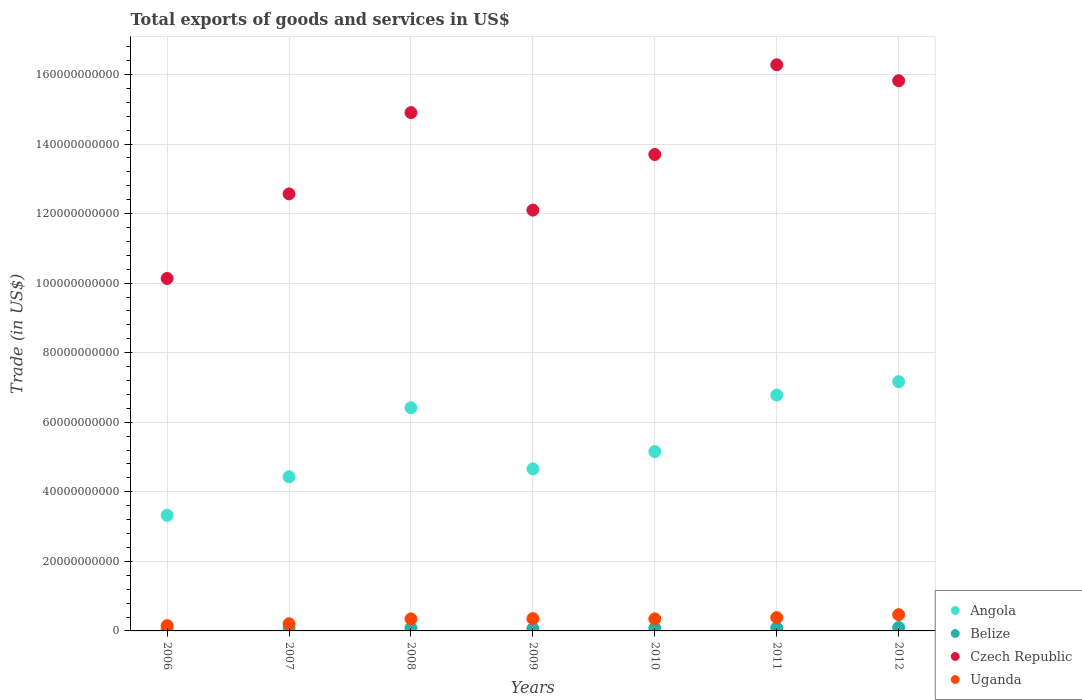What is the total exports of goods and services in Angola in 2012?
Offer a very short reply. 7.17e+1. Across all years, what is the maximum total exports of goods and services in Uganda?
Keep it short and to the point. 4.68e+09. Across all years, what is the minimum total exports of goods and services in Belize?
Make the answer very short. 6.90e+08. In which year was the total exports of goods and services in Angola minimum?
Your answer should be very brief. 2006. What is the total total exports of goods and services in Uganda in the graph?
Give a very brief answer. 2.25e+1. What is the difference between the total exports of goods and services in Uganda in 2008 and that in 2012?
Your answer should be very brief. -1.22e+09. What is the difference between the total exports of goods and services in Czech Republic in 2008 and the total exports of goods and services in Angola in 2009?
Make the answer very short. 1.02e+11. What is the average total exports of goods and services in Belize per year?
Offer a terse response. 8.24e+08. In the year 2007, what is the difference between the total exports of goods and services in Czech Republic and total exports of goods and services in Uganda?
Provide a short and direct response. 1.24e+11. In how many years, is the total exports of goods and services in Belize greater than 124000000000 US$?
Your answer should be compact. 0. What is the ratio of the total exports of goods and services in Czech Republic in 2009 to that in 2012?
Your response must be concise. 0.76. What is the difference between the highest and the second highest total exports of goods and services in Belize?
Offer a terse response. 8.93e+07. What is the difference between the highest and the lowest total exports of goods and services in Belize?
Your response must be concise. 2.93e+08. Does the total exports of goods and services in Uganda monotonically increase over the years?
Your response must be concise. No. Is the total exports of goods and services in Uganda strictly greater than the total exports of goods and services in Czech Republic over the years?
Give a very brief answer. No. Is the total exports of goods and services in Angola strictly less than the total exports of goods and services in Czech Republic over the years?
Ensure brevity in your answer.  Yes. How many years are there in the graph?
Provide a short and direct response. 7. Where does the legend appear in the graph?
Your answer should be compact. Bottom right. How many legend labels are there?
Your answer should be compact. 4. How are the legend labels stacked?
Keep it short and to the point. Vertical. What is the title of the graph?
Keep it short and to the point. Total exports of goods and services in US$. What is the label or title of the X-axis?
Your answer should be compact. Years. What is the label or title of the Y-axis?
Ensure brevity in your answer.  Trade (in US$). What is the Trade (in US$) of Angola in 2006?
Keep it short and to the point. 3.32e+1. What is the Trade (in US$) of Belize in 2006?
Offer a terse response. 7.44e+08. What is the Trade (in US$) in Czech Republic in 2006?
Make the answer very short. 1.01e+11. What is the Trade (in US$) of Uganda in 2006?
Offer a terse response. 1.52e+09. What is the Trade (in US$) in Angola in 2007?
Provide a short and direct response. 4.43e+1. What is the Trade (in US$) in Belize in 2007?
Your response must be concise. 7.88e+08. What is the Trade (in US$) of Czech Republic in 2007?
Ensure brevity in your answer.  1.26e+11. What is the Trade (in US$) in Uganda in 2007?
Offer a terse response. 2.06e+09. What is the Trade (in US$) in Angola in 2008?
Ensure brevity in your answer.  6.42e+1. What is the Trade (in US$) in Belize in 2008?
Your response must be concise. 8.54e+08. What is the Trade (in US$) of Czech Republic in 2008?
Offer a very short reply. 1.49e+11. What is the Trade (in US$) in Uganda in 2008?
Your answer should be very brief. 3.46e+09. What is the Trade (in US$) in Angola in 2009?
Your answer should be compact. 4.66e+1. What is the Trade (in US$) in Belize in 2009?
Offer a very short reply. 6.90e+08. What is the Trade (in US$) in Czech Republic in 2009?
Provide a short and direct response. 1.21e+11. What is the Trade (in US$) in Uganda in 2009?
Offer a very short reply. 3.54e+09. What is the Trade (in US$) in Angola in 2010?
Provide a succinct answer. 5.16e+1. What is the Trade (in US$) of Belize in 2010?
Your response must be concise. 8.13e+08. What is the Trade (in US$) in Czech Republic in 2010?
Ensure brevity in your answer.  1.37e+11. What is the Trade (in US$) of Uganda in 2010?
Your answer should be compact. 3.46e+09. What is the Trade (in US$) of Angola in 2011?
Make the answer very short. 6.78e+1. What is the Trade (in US$) of Belize in 2011?
Your response must be concise. 8.94e+08. What is the Trade (in US$) of Czech Republic in 2011?
Give a very brief answer. 1.63e+11. What is the Trade (in US$) in Uganda in 2011?
Offer a very short reply. 3.84e+09. What is the Trade (in US$) in Angola in 2012?
Provide a succinct answer. 7.17e+1. What is the Trade (in US$) of Belize in 2012?
Your answer should be compact. 9.83e+08. What is the Trade (in US$) of Czech Republic in 2012?
Provide a succinct answer. 1.58e+11. What is the Trade (in US$) of Uganda in 2012?
Give a very brief answer. 4.68e+09. Across all years, what is the maximum Trade (in US$) in Angola?
Your response must be concise. 7.17e+1. Across all years, what is the maximum Trade (in US$) in Belize?
Provide a succinct answer. 9.83e+08. Across all years, what is the maximum Trade (in US$) of Czech Republic?
Ensure brevity in your answer.  1.63e+11. Across all years, what is the maximum Trade (in US$) of Uganda?
Your response must be concise. 4.68e+09. Across all years, what is the minimum Trade (in US$) in Angola?
Keep it short and to the point. 3.32e+1. Across all years, what is the minimum Trade (in US$) of Belize?
Your response must be concise. 6.90e+08. Across all years, what is the minimum Trade (in US$) in Czech Republic?
Offer a very short reply. 1.01e+11. Across all years, what is the minimum Trade (in US$) of Uganda?
Your answer should be very brief. 1.52e+09. What is the total Trade (in US$) of Angola in the graph?
Provide a short and direct response. 3.79e+11. What is the total Trade (in US$) of Belize in the graph?
Offer a terse response. 5.77e+09. What is the total Trade (in US$) in Czech Republic in the graph?
Keep it short and to the point. 9.55e+11. What is the total Trade (in US$) of Uganda in the graph?
Provide a succinct answer. 2.25e+1. What is the difference between the Trade (in US$) of Angola in 2006 and that in 2007?
Provide a succinct answer. -1.11e+1. What is the difference between the Trade (in US$) of Belize in 2006 and that in 2007?
Your response must be concise. -4.42e+07. What is the difference between the Trade (in US$) of Czech Republic in 2006 and that in 2007?
Your answer should be compact. -2.43e+1. What is the difference between the Trade (in US$) in Uganda in 2006 and that in 2007?
Your response must be concise. -5.37e+08. What is the difference between the Trade (in US$) in Angola in 2006 and that in 2008?
Your response must be concise. -3.09e+1. What is the difference between the Trade (in US$) of Belize in 2006 and that in 2008?
Ensure brevity in your answer.  -1.09e+08. What is the difference between the Trade (in US$) in Czech Republic in 2006 and that in 2008?
Provide a succinct answer. -4.77e+1. What is the difference between the Trade (in US$) of Uganda in 2006 and that in 2008?
Your response must be concise. -1.94e+09. What is the difference between the Trade (in US$) of Angola in 2006 and that in 2009?
Your answer should be very brief. -1.34e+1. What is the difference between the Trade (in US$) of Belize in 2006 and that in 2009?
Your answer should be compact. 5.41e+07. What is the difference between the Trade (in US$) of Czech Republic in 2006 and that in 2009?
Provide a succinct answer. -1.97e+1. What is the difference between the Trade (in US$) in Uganda in 2006 and that in 2009?
Give a very brief answer. -2.02e+09. What is the difference between the Trade (in US$) of Angola in 2006 and that in 2010?
Offer a terse response. -1.83e+1. What is the difference between the Trade (in US$) in Belize in 2006 and that in 2010?
Provide a succinct answer. -6.90e+07. What is the difference between the Trade (in US$) of Czech Republic in 2006 and that in 2010?
Ensure brevity in your answer.  -3.57e+1. What is the difference between the Trade (in US$) in Uganda in 2006 and that in 2010?
Your answer should be very brief. -1.94e+09. What is the difference between the Trade (in US$) in Angola in 2006 and that in 2011?
Offer a very short reply. -3.46e+1. What is the difference between the Trade (in US$) in Belize in 2006 and that in 2011?
Offer a very short reply. -1.49e+08. What is the difference between the Trade (in US$) in Czech Republic in 2006 and that in 2011?
Make the answer very short. -6.15e+1. What is the difference between the Trade (in US$) of Uganda in 2006 and that in 2011?
Your answer should be compact. -2.32e+09. What is the difference between the Trade (in US$) of Angola in 2006 and that in 2012?
Provide a short and direct response. -3.84e+1. What is the difference between the Trade (in US$) of Belize in 2006 and that in 2012?
Ensure brevity in your answer.  -2.39e+08. What is the difference between the Trade (in US$) of Czech Republic in 2006 and that in 2012?
Offer a very short reply. -5.69e+1. What is the difference between the Trade (in US$) of Uganda in 2006 and that in 2012?
Offer a terse response. -3.16e+09. What is the difference between the Trade (in US$) of Angola in 2007 and that in 2008?
Ensure brevity in your answer.  -1.98e+1. What is the difference between the Trade (in US$) in Belize in 2007 and that in 2008?
Your response must be concise. -6.52e+07. What is the difference between the Trade (in US$) of Czech Republic in 2007 and that in 2008?
Your answer should be very brief. -2.34e+1. What is the difference between the Trade (in US$) of Uganda in 2007 and that in 2008?
Provide a short and direct response. -1.40e+09. What is the difference between the Trade (in US$) in Angola in 2007 and that in 2009?
Give a very brief answer. -2.28e+09. What is the difference between the Trade (in US$) of Belize in 2007 and that in 2009?
Your answer should be compact. 9.82e+07. What is the difference between the Trade (in US$) in Czech Republic in 2007 and that in 2009?
Your response must be concise. 4.67e+09. What is the difference between the Trade (in US$) of Uganda in 2007 and that in 2009?
Your answer should be compact. -1.49e+09. What is the difference between the Trade (in US$) in Angola in 2007 and that in 2010?
Your response must be concise. -7.25e+09. What is the difference between the Trade (in US$) of Belize in 2007 and that in 2010?
Offer a terse response. -2.49e+07. What is the difference between the Trade (in US$) in Czech Republic in 2007 and that in 2010?
Make the answer very short. -1.13e+1. What is the difference between the Trade (in US$) in Uganda in 2007 and that in 2010?
Give a very brief answer. -1.40e+09. What is the difference between the Trade (in US$) in Angola in 2007 and that in 2011?
Your answer should be compact. -2.35e+1. What is the difference between the Trade (in US$) in Belize in 2007 and that in 2011?
Your response must be concise. -1.05e+08. What is the difference between the Trade (in US$) of Czech Republic in 2007 and that in 2011?
Your response must be concise. -3.71e+1. What is the difference between the Trade (in US$) of Uganda in 2007 and that in 2011?
Keep it short and to the point. -1.78e+09. What is the difference between the Trade (in US$) in Angola in 2007 and that in 2012?
Your response must be concise. -2.73e+1. What is the difference between the Trade (in US$) of Belize in 2007 and that in 2012?
Offer a very short reply. -1.94e+08. What is the difference between the Trade (in US$) in Czech Republic in 2007 and that in 2012?
Keep it short and to the point. -3.25e+1. What is the difference between the Trade (in US$) of Uganda in 2007 and that in 2012?
Offer a terse response. -2.62e+09. What is the difference between the Trade (in US$) of Angola in 2008 and that in 2009?
Your answer should be very brief. 1.76e+1. What is the difference between the Trade (in US$) of Belize in 2008 and that in 2009?
Offer a very short reply. 1.63e+08. What is the difference between the Trade (in US$) of Czech Republic in 2008 and that in 2009?
Offer a terse response. 2.80e+1. What is the difference between the Trade (in US$) of Uganda in 2008 and that in 2009?
Your answer should be very brief. -8.52e+07. What is the difference between the Trade (in US$) in Angola in 2008 and that in 2010?
Make the answer very short. 1.26e+1. What is the difference between the Trade (in US$) of Belize in 2008 and that in 2010?
Your answer should be very brief. 4.03e+07. What is the difference between the Trade (in US$) of Czech Republic in 2008 and that in 2010?
Offer a very short reply. 1.20e+1. What is the difference between the Trade (in US$) of Uganda in 2008 and that in 2010?
Ensure brevity in your answer.  -1.05e+06. What is the difference between the Trade (in US$) in Angola in 2008 and that in 2011?
Offer a very short reply. -3.65e+09. What is the difference between the Trade (in US$) in Belize in 2008 and that in 2011?
Keep it short and to the point. -4.00e+07. What is the difference between the Trade (in US$) of Czech Republic in 2008 and that in 2011?
Your response must be concise. -1.38e+1. What is the difference between the Trade (in US$) of Uganda in 2008 and that in 2011?
Give a very brief answer. -3.80e+08. What is the difference between the Trade (in US$) in Angola in 2008 and that in 2012?
Make the answer very short. -7.50e+09. What is the difference between the Trade (in US$) in Belize in 2008 and that in 2012?
Give a very brief answer. -1.29e+08. What is the difference between the Trade (in US$) of Czech Republic in 2008 and that in 2012?
Make the answer very short. -9.17e+09. What is the difference between the Trade (in US$) of Uganda in 2008 and that in 2012?
Your response must be concise. -1.22e+09. What is the difference between the Trade (in US$) in Angola in 2009 and that in 2010?
Provide a succinct answer. -4.98e+09. What is the difference between the Trade (in US$) of Belize in 2009 and that in 2010?
Provide a succinct answer. -1.23e+08. What is the difference between the Trade (in US$) of Czech Republic in 2009 and that in 2010?
Offer a terse response. -1.60e+1. What is the difference between the Trade (in US$) in Uganda in 2009 and that in 2010?
Keep it short and to the point. 8.41e+07. What is the difference between the Trade (in US$) of Angola in 2009 and that in 2011?
Your answer should be very brief. -2.12e+1. What is the difference between the Trade (in US$) in Belize in 2009 and that in 2011?
Give a very brief answer. -2.03e+08. What is the difference between the Trade (in US$) in Czech Republic in 2009 and that in 2011?
Offer a terse response. -4.18e+1. What is the difference between the Trade (in US$) of Uganda in 2009 and that in 2011?
Give a very brief answer. -2.95e+08. What is the difference between the Trade (in US$) in Angola in 2009 and that in 2012?
Keep it short and to the point. -2.51e+1. What is the difference between the Trade (in US$) in Belize in 2009 and that in 2012?
Make the answer very short. -2.93e+08. What is the difference between the Trade (in US$) in Czech Republic in 2009 and that in 2012?
Offer a very short reply. -3.72e+1. What is the difference between the Trade (in US$) of Uganda in 2009 and that in 2012?
Provide a succinct answer. -1.13e+09. What is the difference between the Trade (in US$) in Angola in 2010 and that in 2011?
Provide a succinct answer. -1.62e+1. What is the difference between the Trade (in US$) of Belize in 2010 and that in 2011?
Make the answer very short. -8.03e+07. What is the difference between the Trade (in US$) in Czech Republic in 2010 and that in 2011?
Make the answer very short. -2.58e+1. What is the difference between the Trade (in US$) in Uganda in 2010 and that in 2011?
Ensure brevity in your answer.  -3.79e+08. What is the difference between the Trade (in US$) in Angola in 2010 and that in 2012?
Provide a short and direct response. -2.01e+1. What is the difference between the Trade (in US$) in Belize in 2010 and that in 2012?
Keep it short and to the point. -1.70e+08. What is the difference between the Trade (in US$) of Czech Republic in 2010 and that in 2012?
Your response must be concise. -2.12e+1. What is the difference between the Trade (in US$) in Uganda in 2010 and that in 2012?
Your response must be concise. -1.22e+09. What is the difference between the Trade (in US$) in Angola in 2011 and that in 2012?
Your answer should be very brief. -3.85e+09. What is the difference between the Trade (in US$) of Belize in 2011 and that in 2012?
Provide a short and direct response. -8.93e+07. What is the difference between the Trade (in US$) in Czech Republic in 2011 and that in 2012?
Provide a succinct answer. 4.59e+09. What is the difference between the Trade (in US$) of Uganda in 2011 and that in 2012?
Your response must be concise. -8.39e+08. What is the difference between the Trade (in US$) of Angola in 2006 and the Trade (in US$) of Belize in 2007?
Offer a very short reply. 3.25e+1. What is the difference between the Trade (in US$) of Angola in 2006 and the Trade (in US$) of Czech Republic in 2007?
Make the answer very short. -9.24e+1. What is the difference between the Trade (in US$) of Angola in 2006 and the Trade (in US$) of Uganda in 2007?
Make the answer very short. 3.12e+1. What is the difference between the Trade (in US$) in Belize in 2006 and the Trade (in US$) in Czech Republic in 2007?
Keep it short and to the point. -1.25e+11. What is the difference between the Trade (in US$) in Belize in 2006 and the Trade (in US$) in Uganda in 2007?
Offer a terse response. -1.31e+09. What is the difference between the Trade (in US$) of Czech Republic in 2006 and the Trade (in US$) of Uganda in 2007?
Keep it short and to the point. 9.93e+1. What is the difference between the Trade (in US$) of Angola in 2006 and the Trade (in US$) of Belize in 2008?
Your response must be concise. 3.24e+1. What is the difference between the Trade (in US$) of Angola in 2006 and the Trade (in US$) of Czech Republic in 2008?
Offer a terse response. -1.16e+11. What is the difference between the Trade (in US$) in Angola in 2006 and the Trade (in US$) in Uganda in 2008?
Your response must be concise. 2.98e+1. What is the difference between the Trade (in US$) in Belize in 2006 and the Trade (in US$) in Czech Republic in 2008?
Ensure brevity in your answer.  -1.48e+11. What is the difference between the Trade (in US$) in Belize in 2006 and the Trade (in US$) in Uganda in 2008?
Provide a succinct answer. -2.71e+09. What is the difference between the Trade (in US$) in Czech Republic in 2006 and the Trade (in US$) in Uganda in 2008?
Make the answer very short. 9.79e+1. What is the difference between the Trade (in US$) of Angola in 2006 and the Trade (in US$) of Belize in 2009?
Provide a short and direct response. 3.26e+1. What is the difference between the Trade (in US$) of Angola in 2006 and the Trade (in US$) of Czech Republic in 2009?
Your answer should be compact. -8.78e+1. What is the difference between the Trade (in US$) in Angola in 2006 and the Trade (in US$) in Uganda in 2009?
Ensure brevity in your answer.  2.97e+1. What is the difference between the Trade (in US$) of Belize in 2006 and the Trade (in US$) of Czech Republic in 2009?
Ensure brevity in your answer.  -1.20e+11. What is the difference between the Trade (in US$) in Belize in 2006 and the Trade (in US$) in Uganda in 2009?
Provide a short and direct response. -2.80e+09. What is the difference between the Trade (in US$) of Czech Republic in 2006 and the Trade (in US$) of Uganda in 2009?
Offer a very short reply. 9.78e+1. What is the difference between the Trade (in US$) of Angola in 2006 and the Trade (in US$) of Belize in 2010?
Give a very brief answer. 3.24e+1. What is the difference between the Trade (in US$) in Angola in 2006 and the Trade (in US$) in Czech Republic in 2010?
Your answer should be compact. -1.04e+11. What is the difference between the Trade (in US$) in Angola in 2006 and the Trade (in US$) in Uganda in 2010?
Provide a short and direct response. 2.98e+1. What is the difference between the Trade (in US$) of Belize in 2006 and the Trade (in US$) of Czech Republic in 2010?
Provide a short and direct response. -1.36e+11. What is the difference between the Trade (in US$) in Belize in 2006 and the Trade (in US$) in Uganda in 2010?
Keep it short and to the point. -2.71e+09. What is the difference between the Trade (in US$) in Czech Republic in 2006 and the Trade (in US$) in Uganda in 2010?
Provide a short and direct response. 9.79e+1. What is the difference between the Trade (in US$) in Angola in 2006 and the Trade (in US$) in Belize in 2011?
Keep it short and to the point. 3.24e+1. What is the difference between the Trade (in US$) in Angola in 2006 and the Trade (in US$) in Czech Republic in 2011?
Provide a succinct answer. -1.30e+11. What is the difference between the Trade (in US$) of Angola in 2006 and the Trade (in US$) of Uganda in 2011?
Provide a short and direct response. 2.94e+1. What is the difference between the Trade (in US$) of Belize in 2006 and the Trade (in US$) of Czech Republic in 2011?
Provide a short and direct response. -1.62e+11. What is the difference between the Trade (in US$) of Belize in 2006 and the Trade (in US$) of Uganda in 2011?
Provide a short and direct response. -3.09e+09. What is the difference between the Trade (in US$) of Czech Republic in 2006 and the Trade (in US$) of Uganda in 2011?
Your answer should be very brief. 9.75e+1. What is the difference between the Trade (in US$) in Angola in 2006 and the Trade (in US$) in Belize in 2012?
Give a very brief answer. 3.23e+1. What is the difference between the Trade (in US$) of Angola in 2006 and the Trade (in US$) of Czech Republic in 2012?
Offer a very short reply. -1.25e+11. What is the difference between the Trade (in US$) in Angola in 2006 and the Trade (in US$) in Uganda in 2012?
Your response must be concise. 2.86e+1. What is the difference between the Trade (in US$) of Belize in 2006 and the Trade (in US$) of Czech Republic in 2012?
Provide a short and direct response. -1.57e+11. What is the difference between the Trade (in US$) of Belize in 2006 and the Trade (in US$) of Uganda in 2012?
Provide a succinct answer. -3.93e+09. What is the difference between the Trade (in US$) of Czech Republic in 2006 and the Trade (in US$) of Uganda in 2012?
Offer a very short reply. 9.67e+1. What is the difference between the Trade (in US$) of Angola in 2007 and the Trade (in US$) of Belize in 2008?
Your answer should be compact. 4.35e+1. What is the difference between the Trade (in US$) in Angola in 2007 and the Trade (in US$) in Czech Republic in 2008?
Your answer should be compact. -1.05e+11. What is the difference between the Trade (in US$) in Angola in 2007 and the Trade (in US$) in Uganda in 2008?
Your answer should be compact. 4.09e+1. What is the difference between the Trade (in US$) in Belize in 2007 and the Trade (in US$) in Czech Republic in 2008?
Your response must be concise. -1.48e+11. What is the difference between the Trade (in US$) of Belize in 2007 and the Trade (in US$) of Uganda in 2008?
Your answer should be very brief. -2.67e+09. What is the difference between the Trade (in US$) of Czech Republic in 2007 and the Trade (in US$) of Uganda in 2008?
Offer a terse response. 1.22e+11. What is the difference between the Trade (in US$) in Angola in 2007 and the Trade (in US$) in Belize in 2009?
Your response must be concise. 4.36e+1. What is the difference between the Trade (in US$) of Angola in 2007 and the Trade (in US$) of Czech Republic in 2009?
Provide a succinct answer. -7.67e+1. What is the difference between the Trade (in US$) in Angola in 2007 and the Trade (in US$) in Uganda in 2009?
Provide a succinct answer. 4.08e+1. What is the difference between the Trade (in US$) of Belize in 2007 and the Trade (in US$) of Czech Republic in 2009?
Provide a succinct answer. -1.20e+11. What is the difference between the Trade (in US$) of Belize in 2007 and the Trade (in US$) of Uganda in 2009?
Give a very brief answer. -2.75e+09. What is the difference between the Trade (in US$) in Czech Republic in 2007 and the Trade (in US$) in Uganda in 2009?
Provide a short and direct response. 1.22e+11. What is the difference between the Trade (in US$) in Angola in 2007 and the Trade (in US$) in Belize in 2010?
Make the answer very short. 4.35e+1. What is the difference between the Trade (in US$) of Angola in 2007 and the Trade (in US$) of Czech Republic in 2010?
Offer a terse response. -9.27e+1. What is the difference between the Trade (in US$) of Angola in 2007 and the Trade (in US$) of Uganda in 2010?
Offer a very short reply. 4.09e+1. What is the difference between the Trade (in US$) of Belize in 2007 and the Trade (in US$) of Czech Republic in 2010?
Keep it short and to the point. -1.36e+11. What is the difference between the Trade (in US$) in Belize in 2007 and the Trade (in US$) in Uganda in 2010?
Your answer should be very brief. -2.67e+09. What is the difference between the Trade (in US$) in Czech Republic in 2007 and the Trade (in US$) in Uganda in 2010?
Your response must be concise. 1.22e+11. What is the difference between the Trade (in US$) of Angola in 2007 and the Trade (in US$) of Belize in 2011?
Your response must be concise. 4.34e+1. What is the difference between the Trade (in US$) of Angola in 2007 and the Trade (in US$) of Czech Republic in 2011?
Provide a succinct answer. -1.18e+11. What is the difference between the Trade (in US$) of Angola in 2007 and the Trade (in US$) of Uganda in 2011?
Provide a succinct answer. 4.05e+1. What is the difference between the Trade (in US$) of Belize in 2007 and the Trade (in US$) of Czech Republic in 2011?
Make the answer very short. -1.62e+11. What is the difference between the Trade (in US$) in Belize in 2007 and the Trade (in US$) in Uganda in 2011?
Provide a short and direct response. -3.05e+09. What is the difference between the Trade (in US$) in Czech Republic in 2007 and the Trade (in US$) in Uganda in 2011?
Provide a succinct answer. 1.22e+11. What is the difference between the Trade (in US$) in Angola in 2007 and the Trade (in US$) in Belize in 2012?
Ensure brevity in your answer.  4.33e+1. What is the difference between the Trade (in US$) of Angola in 2007 and the Trade (in US$) of Czech Republic in 2012?
Keep it short and to the point. -1.14e+11. What is the difference between the Trade (in US$) in Angola in 2007 and the Trade (in US$) in Uganda in 2012?
Give a very brief answer. 3.96e+1. What is the difference between the Trade (in US$) in Belize in 2007 and the Trade (in US$) in Czech Republic in 2012?
Offer a terse response. -1.57e+11. What is the difference between the Trade (in US$) in Belize in 2007 and the Trade (in US$) in Uganda in 2012?
Give a very brief answer. -3.89e+09. What is the difference between the Trade (in US$) in Czech Republic in 2007 and the Trade (in US$) in Uganda in 2012?
Provide a succinct answer. 1.21e+11. What is the difference between the Trade (in US$) of Angola in 2008 and the Trade (in US$) of Belize in 2009?
Your answer should be compact. 6.35e+1. What is the difference between the Trade (in US$) in Angola in 2008 and the Trade (in US$) in Czech Republic in 2009?
Your answer should be compact. -5.68e+1. What is the difference between the Trade (in US$) of Angola in 2008 and the Trade (in US$) of Uganda in 2009?
Ensure brevity in your answer.  6.06e+1. What is the difference between the Trade (in US$) of Belize in 2008 and the Trade (in US$) of Czech Republic in 2009?
Offer a very short reply. -1.20e+11. What is the difference between the Trade (in US$) of Belize in 2008 and the Trade (in US$) of Uganda in 2009?
Offer a very short reply. -2.69e+09. What is the difference between the Trade (in US$) in Czech Republic in 2008 and the Trade (in US$) in Uganda in 2009?
Make the answer very short. 1.45e+11. What is the difference between the Trade (in US$) of Angola in 2008 and the Trade (in US$) of Belize in 2010?
Your answer should be very brief. 6.34e+1. What is the difference between the Trade (in US$) of Angola in 2008 and the Trade (in US$) of Czech Republic in 2010?
Your answer should be very brief. -7.28e+1. What is the difference between the Trade (in US$) in Angola in 2008 and the Trade (in US$) in Uganda in 2010?
Provide a short and direct response. 6.07e+1. What is the difference between the Trade (in US$) in Belize in 2008 and the Trade (in US$) in Czech Republic in 2010?
Give a very brief answer. -1.36e+11. What is the difference between the Trade (in US$) of Belize in 2008 and the Trade (in US$) of Uganda in 2010?
Provide a succinct answer. -2.60e+09. What is the difference between the Trade (in US$) of Czech Republic in 2008 and the Trade (in US$) of Uganda in 2010?
Offer a terse response. 1.46e+11. What is the difference between the Trade (in US$) of Angola in 2008 and the Trade (in US$) of Belize in 2011?
Provide a succinct answer. 6.33e+1. What is the difference between the Trade (in US$) of Angola in 2008 and the Trade (in US$) of Czech Republic in 2011?
Provide a succinct answer. -9.86e+1. What is the difference between the Trade (in US$) of Angola in 2008 and the Trade (in US$) of Uganda in 2011?
Offer a very short reply. 6.03e+1. What is the difference between the Trade (in US$) in Belize in 2008 and the Trade (in US$) in Czech Republic in 2011?
Keep it short and to the point. -1.62e+11. What is the difference between the Trade (in US$) in Belize in 2008 and the Trade (in US$) in Uganda in 2011?
Give a very brief answer. -2.98e+09. What is the difference between the Trade (in US$) in Czech Republic in 2008 and the Trade (in US$) in Uganda in 2011?
Ensure brevity in your answer.  1.45e+11. What is the difference between the Trade (in US$) of Angola in 2008 and the Trade (in US$) of Belize in 2012?
Ensure brevity in your answer.  6.32e+1. What is the difference between the Trade (in US$) in Angola in 2008 and the Trade (in US$) in Czech Republic in 2012?
Your answer should be compact. -9.40e+1. What is the difference between the Trade (in US$) of Angola in 2008 and the Trade (in US$) of Uganda in 2012?
Your answer should be compact. 5.95e+1. What is the difference between the Trade (in US$) of Belize in 2008 and the Trade (in US$) of Czech Republic in 2012?
Provide a succinct answer. -1.57e+11. What is the difference between the Trade (in US$) of Belize in 2008 and the Trade (in US$) of Uganda in 2012?
Give a very brief answer. -3.82e+09. What is the difference between the Trade (in US$) of Czech Republic in 2008 and the Trade (in US$) of Uganda in 2012?
Your response must be concise. 1.44e+11. What is the difference between the Trade (in US$) of Angola in 2009 and the Trade (in US$) of Belize in 2010?
Provide a short and direct response. 4.58e+1. What is the difference between the Trade (in US$) of Angola in 2009 and the Trade (in US$) of Czech Republic in 2010?
Your response must be concise. -9.04e+1. What is the difference between the Trade (in US$) in Angola in 2009 and the Trade (in US$) in Uganda in 2010?
Offer a very short reply. 4.31e+1. What is the difference between the Trade (in US$) of Belize in 2009 and the Trade (in US$) of Czech Republic in 2010?
Offer a terse response. -1.36e+11. What is the difference between the Trade (in US$) of Belize in 2009 and the Trade (in US$) of Uganda in 2010?
Provide a short and direct response. -2.77e+09. What is the difference between the Trade (in US$) in Czech Republic in 2009 and the Trade (in US$) in Uganda in 2010?
Ensure brevity in your answer.  1.18e+11. What is the difference between the Trade (in US$) of Angola in 2009 and the Trade (in US$) of Belize in 2011?
Your answer should be very brief. 4.57e+1. What is the difference between the Trade (in US$) in Angola in 2009 and the Trade (in US$) in Czech Republic in 2011?
Provide a short and direct response. -1.16e+11. What is the difference between the Trade (in US$) of Angola in 2009 and the Trade (in US$) of Uganda in 2011?
Offer a very short reply. 4.28e+1. What is the difference between the Trade (in US$) of Belize in 2009 and the Trade (in US$) of Czech Republic in 2011?
Give a very brief answer. -1.62e+11. What is the difference between the Trade (in US$) in Belize in 2009 and the Trade (in US$) in Uganda in 2011?
Offer a terse response. -3.15e+09. What is the difference between the Trade (in US$) in Czech Republic in 2009 and the Trade (in US$) in Uganda in 2011?
Your response must be concise. 1.17e+11. What is the difference between the Trade (in US$) in Angola in 2009 and the Trade (in US$) in Belize in 2012?
Your answer should be very brief. 4.56e+1. What is the difference between the Trade (in US$) of Angola in 2009 and the Trade (in US$) of Czech Republic in 2012?
Your response must be concise. -1.12e+11. What is the difference between the Trade (in US$) of Angola in 2009 and the Trade (in US$) of Uganda in 2012?
Give a very brief answer. 4.19e+1. What is the difference between the Trade (in US$) of Belize in 2009 and the Trade (in US$) of Czech Republic in 2012?
Your answer should be compact. -1.58e+11. What is the difference between the Trade (in US$) in Belize in 2009 and the Trade (in US$) in Uganda in 2012?
Offer a terse response. -3.99e+09. What is the difference between the Trade (in US$) in Czech Republic in 2009 and the Trade (in US$) in Uganda in 2012?
Ensure brevity in your answer.  1.16e+11. What is the difference between the Trade (in US$) of Angola in 2010 and the Trade (in US$) of Belize in 2011?
Ensure brevity in your answer.  5.07e+1. What is the difference between the Trade (in US$) in Angola in 2010 and the Trade (in US$) in Czech Republic in 2011?
Give a very brief answer. -1.11e+11. What is the difference between the Trade (in US$) in Angola in 2010 and the Trade (in US$) in Uganda in 2011?
Your answer should be very brief. 4.77e+1. What is the difference between the Trade (in US$) in Belize in 2010 and the Trade (in US$) in Czech Republic in 2011?
Ensure brevity in your answer.  -1.62e+11. What is the difference between the Trade (in US$) of Belize in 2010 and the Trade (in US$) of Uganda in 2011?
Your answer should be compact. -3.02e+09. What is the difference between the Trade (in US$) of Czech Republic in 2010 and the Trade (in US$) of Uganda in 2011?
Give a very brief answer. 1.33e+11. What is the difference between the Trade (in US$) of Angola in 2010 and the Trade (in US$) of Belize in 2012?
Make the answer very short. 5.06e+1. What is the difference between the Trade (in US$) in Angola in 2010 and the Trade (in US$) in Czech Republic in 2012?
Make the answer very short. -1.07e+11. What is the difference between the Trade (in US$) of Angola in 2010 and the Trade (in US$) of Uganda in 2012?
Give a very brief answer. 4.69e+1. What is the difference between the Trade (in US$) in Belize in 2010 and the Trade (in US$) in Czech Republic in 2012?
Your response must be concise. -1.57e+11. What is the difference between the Trade (in US$) in Belize in 2010 and the Trade (in US$) in Uganda in 2012?
Your answer should be very brief. -3.86e+09. What is the difference between the Trade (in US$) of Czech Republic in 2010 and the Trade (in US$) of Uganda in 2012?
Ensure brevity in your answer.  1.32e+11. What is the difference between the Trade (in US$) in Angola in 2011 and the Trade (in US$) in Belize in 2012?
Provide a short and direct response. 6.68e+1. What is the difference between the Trade (in US$) in Angola in 2011 and the Trade (in US$) in Czech Republic in 2012?
Offer a terse response. -9.04e+1. What is the difference between the Trade (in US$) in Angola in 2011 and the Trade (in US$) in Uganda in 2012?
Your response must be concise. 6.31e+1. What is the difference between the Trade (in US$) in Belize in 2011 and the Trade (in US$) in Czech Republic in 2012?
Provide a succinct answer. -1.57e+11. What is the difference between the Trade (in US$) of Belize in 2011 and the Trade (in US$) of Uganda in 2012?
Make the answer very short. -3.78e+09. What is the difference between the Trade (in US$) in Czech Republic in 2011 and the Trade (in US$) in Uganda in 2012?
Keep it short and to the point. 1.58e+11. What is the average Trade (in US$) of Angola per year?
Your answer should be very brief. 5.42e+1. What is the average Trade (in US$) in Belize per year?
Offer a terse response. 8.24e+08. What is the average Trade (in US$) of Czech Republic per year?
Give a very brief answer. 1.36e+11. What is the average Trade (in US$) in Uganda per year?
Make the answer very short. 3.22e+09. In the year 2006, what is the difference between the Trade (in US$) of Angola and Trade (in US$) of Belize?
Offer a very short reply. 3.25e+1. In the year 2006, what is the difference between the Trade (in US$) of Angola and Trade (in US$) of Czech Republic?
Ensure brevity in your answer.  -6.81e+1. In the year 2006, what is the difference between the Trade (in US$) in Angola and Trade (in US$) in Uganda?
Your answer should be very brief. 3.17e+1. In the year 2006, what is the difference between the Trade (in US$) of Belize and Trade (in US$) of Czech Republic?
Keep it short and to the point. -1.01e+11. In the year 2006, what is the difference between the Trade (in US$) in Belize and Trade (in US$) in Uganda?
Offer a terse response. -7.75e+08. In the year 2006, what is the difference between the Trade (in US$) in Czech Republic and Trade (in US$) in Uganda?
Ensure brevity in your answer.  9.98e+1. In the year 2007, what is the difference between the Trade (in US$) of Angola and Trade (in US$) of Belize?
Offer a terse response. 4.35e+1. In the year 2007, what is the difference between the Trade (in US$) in Angola and Trade (in US$) in Czech Republic?
Give a very brief answer. -8.13e+1. In the year 2007, what is the difference between the Trade (in US$) of Angola and Trade (in US$) of Uganda?
Your response must be concise. 4.23e+1. In the year 2007, what is the difference between the Trade (in US$) in Belize and Trade (in US$) in Czech Republic?
Offer a very short reply. -1.25e+11. In the year 2007, what is the difference between the Trade (in US$) in Belize and Trade (in US$) in Uganda?
Ensure brevity in your answer.  -1.27e+09. In the year 2007, what is the difference between the Trade (in US$) in Czech Republic and Trade (in US$) in Uganda?
Offer a very short reply. 1.24e+11. In the year 2008, what is the difference between the Trade (in US$) of Angola and Trade (in US$) of Belize?
Provide a succinct answer. 6.33e+1. In the year 2008, what is the difference between the Trade (in US$) in Angola and Trade (in US$) in Czech Republic?
Your response must be concise. -8.49e+1. In the year 2008, what is the difference between the Trade (in US$) in Angola and Trade (in US$) in Uganda?
Your answer should be very brief. 6.07e+1. In the year 2008, what is the difference between the Trade (in US$) in Belize and Trade (in US$) in Czech Republic?
Provide a short and direct response. -1.48e+11. In the year 2008, what is the difference between the Trade (in US$) in Belize and Trade (in US$) in Uganda?
Keep it short and to the point. -2.60e+09. In the year 2008, what is the difference between the Trade (in US$) of Czech Republic and Trade (in US$) of Uganda?
Offer a very short reply. 1.46e+11. In the year 2009, what is the difference between the Trade (in US$) in Angola and Trade (in US$) in Belize?
Provide a short and direct response. 4.59e+1. In the year 2009, what is the difference between the Trade (in US$) of Angola and Trade (in US$) of Czech Republic?
Your response must be concise. -7.44e+1. In the year 2009, what is the difference between the Trade (in US$) of Angola and Trade (in US$) of Uganda?
Provide a short and direct response. 4.31e+1. In the year 2009, what is the difference between the Trade (in US$) of Belize and Trade (in US$) of Czech Republic?
Offer a very short reply. -1.20e+11. In the year 2009, what is the difference between the Trade (in US$) in Belize and Trade (in US$) in Uganda?
Your response must be concise. -2.85e+09. In the year 2009, what is the difference between the Trade (in US$) in Czech Republic and Trade (in US$) in Uganda?
Ensure brevity in your answer.  1.17e+11. In the year 2010, what is the difference between the Trade (in US$) in Angola and Trade (in US$) in Belize?
Keep it short and to the point. 5.08e+1. In the year 2010, what is the difference between the Trade (in US$) in Angola and Trade (in US$) in Czech Republic?
Your answer should be compact. -8.54e+1. In the year 2010, what is the difference between the Trade (in US$) in Angola and Trade (in US$) in Uganda?
Ensure brevity in your answer.  4.81e+1. In the year 2010, what is the difference between the Trade (in US$) in Belize and Trade (in US$) in Czech Republic?
Make the answer very short. -1.36e+11. In the year 2010, what is the difference between the Trade (in US$) of Belize and Trade (in US$) of Uganda?
Provide a short and direct response. -2.65e+09. In the year 2010, what is the difference between the Trade (in US$) of Czech Republic and Trade (in US$) of Uganda?
Keep it short and to the point. 1.34e+11. In the year 2011, what is the difference between the Trade (in US$) of Angola and Trade (in US$) of Belize?
Provide a succinct answer. 6.69e+1. In the year 2011, what is the difference between the Trade (in US$) of Angola and Trade (in US$) of Czech Republic?
Make the answer very short. -9.50e+1. In the year 2011, what is the difference between the Trade (in US$) of Angola and Trade (in US$) of Uganda?
Offer a terse response. 6.40e+1. In the year 2011, what is the difference between the Trade (in US$) in Belize and Trade (in US$) in Czech Republic?
Provide a succinct answer. -1.62e+11. In the year 2011, what is the difference between the Trade (in US$) in Belize and Trade (in US$) in Uganda?
Offer a very short reply. -2.94e+09. In the year 2011, what is the difference between the Trade (in US$) in Czech Republic and Trade (in US$) in Uganda?
Your response must be concise. 1.59e+11. In the year 2012, what is the difference between the Trade (in US$) of Angola and Trade (in US$) of Belize?
Provide a short and direct response. 7.07e+1. In the year 2012, what is the difference between the Trade (in US$) of Angola and Trade (in US$) of Czech Republic?
Your answer should be compact. -8.65e+1. In the year 2012, what is the difference between the Trade (in US$) in Angola and Trade (in US$) in Uganda?
Your response must be concise. 6.70e+1. In the year 2012, what is the difference between the Trade (in US$) in Belize and Trade (in US$) in Czech Republic?
Your answer should be very brief. -1.57e+11. In the year 2012, what is the difference between the Trade (in US$) of Belize and Trade (in US$) of Uganda?
Offer a very short reply. -3.69e+09. In the year 2012, what is the difference between the Trade (in US$) of Czech Republic and Trade (in US$) of Uganda?
Offer a very short reply. 1.54e+11. What is the ratio of the Trade (in US$) of Angola in 2006 to that in 2007?
Offer a very short reply. 0.75. What is the ratio of the Trade (in US$) in Belize in 2006 to that in 2007?
Offer a terse response. 0.94. What is the ratio of the Trade (in US$) of Czech Republic in 2006 to that in 2007?
Your answer should be compact. 0.81. What is the ratio of the Trade (in US$) of Uganda in 2006 to that in 2007?
Your response must be concise. 0.74. What is the ratio of the Trade (in US$) of Angola in 2006 to that in 2008?
Make the answer very short. 0.52. What is the ratio of the Trade (in US$) of Belize in 2006 to that in 2008?
Make the answer very short. 0.87. What is the ratio of the Trade (in US$) of Czech Republic in 2006 to that in 2008?
Your answer should be very brief. 0.68. What is the ratio of the Trade (in US$) in Uganda in 2006 to that in 2008?
Your answer should be compact. 0.44. What is the ratio of the Trade (in US$) in Angola in 2006 to that in 2009?
Offer a very short reply. 0.71. What is the ratio of the Trade (in US$) of Belize in 2006 to that in 2009?
Offer a very short reply. 1.08. What is the ratio of the Trade (in US$) of Czech Republic in 2006 to that in 2009?
Keep it short and to the point. 0.84. What is the ratio of the Trade (in US$) of Uganda in 2006 to that in 2009?
Offer a very short reply. 0.43. What is the ratio of the Trade (in US$) in Angola in 2006 to that in 2010?
Your answer should be compact. 0.64. What is the ratio of the Trade (in US$) in Belize in 2006 to that in 2010?
Make the answer very short. 0.92. What is the ratio of the Trade (in US$) of Czech Republic in 2006 to that in 2010?
Your answer should be compact. 0.74. What is the ratio of the Trade (in US$) in Uganda in 2006 to that in 2010?
Provide a succinct answer. 0.44. What is the ratio of the Trade (in US$) in Angola in 2006 to that in 2011?
Give a very brief answer. 0.49. What is the ratio of the Trade (in US$) in Belize in 2006 to that in 2011?
Your response must be concise. 0.83. What is the ratio of the Trade (in US$) of Czech Republic in 2006 to that in 2011?
Provide a succinct answer. 0.62. What is the ratio of the Trade (in US$) of Uganda in 2006 to that in 2011?
Your answer should be very brief. 0.4. What is the ratio of the Trade (in US$) of Angola in 2006 to that in 2012?
Make the answer very short. 0.46. What is the ratio of the Trade (in US$) in Belize in 2006 to that in 2012?
Provide a short and direct response. 0.76. What is the ratio of the Trade (in US$) of Czech Republic in 2006 to that in 2012?
Provide a short and direct response. 0.64. What is the ratio of the Trade (in US$) of Uganda in 2006 to that in 2012?
Your answer should be very brief. 0.32. What is the ratio of the Trade (in US$) in Angola in 2007 to that in 2008?
Your response must be concise. 0.69. What is the ratio of the Trade (in US$) of Belize in 2007 to that in 2008?
Your response must be concise. 0.92. What is the ratio of the Trade (in US$) in Czech Republic in 2007 to that in 2008?
Your answer should be compact. 0.84. What is the ratio of the Trade (in US$) in Uganda in 2007 to that in 2008?
Your response must be concise. 0.59. What is the ratio of the Trade (in US$) of Angola in 2007 to that in 2009?
Offer a very short reply. 0.95. What is the ratio of the Trade (in US$) in Belize in 2007 to that in 2009?
Provide a short and direct response. 1.14. What is the ratio of the Trade (in US$) in Czech Republic in 2007 to that in 2009?
Provide a succinct answer. 1.04. What is the ratio of the Trade (in US$) in Uganda in 2007 to that in 2009?
Give a very brief answer. 0.58. What is the ratio of the Trade (in US$) in Angola in 2007 to that in 2010?
Provide a succinct answer. 0.86. What is the ratio of the Trade (in US$) in Belize in 2007 to that in 2010?
Offer a terse response. 0.97. What is the ratio of the Trade (in US$) in Czech Republic in 2007 to that in 2010?
Provide a succinct answer. 0.92. What is the ratio of the Trade (in US$) of Uganda in 2007 to that in 2010?
Provide a short and direct response. 0.59. What is the ratio of the Trade (in US$) in Angola in 2007 to that in 2011?
Provide a short and direct response. 0.65. What is the ratio of the Trade (in US$) in Belize in 2007 to that in 2011?
Your answer should be very brief. 0.88. What is the ratio of the Trade (in US$) in Czech Republic in 2007 to that in 2011?
Your answer should be compact. 0.77. What is the ratio of the Trade (in US$) in Uganda in 2007 to that in 2011?
Offer a terse response. 0.54. What is the ratio of the Trade (in US$) of Angola in 2007 to that in 2012?
Keep it short and to the point. 0.62. What is the ratio of the Trade (in US$) in Belize in 2007 to that in 2012?
Keep it short and to the point. 0.8. What is the ratio of the Trade (in US$) of Czech Republic in 2007 to that in 2012?
Keep it short and to the point. 0.79. What is the ratio of the Trade (in US$) of Uganda in 2007 to that in 2012?
Give a very brief answer. 0.44. What is the ratio of the Trade (in US$) of Angola in 2008 to that in 2009?
Ensure brevity in your answer.  1.38. What is the ratio of the Trade (in US$) of Belize in 2008 to that in 2009?
Make the answer very short. 1.24. What is the ratio of the Trade (in US$) of Czech Republic in 2008 to that in 2009?
Your response must be concise. 1.23. What is the ratio of the Trade (in US$) of Uganda in 2008 to that in 2009?
Ensure brevity in your answer.  0.98. What is the ratio of the Trade (in US$) in Angola in 2008 to that in 2010?
Your answer should be very brief. 1.24. What is the ratio of the Trade (in US$) of Belize in 2008 to that in 2010?
Make the answer very short. 1.05. What is the ratio of the Trade (in US$) in Czech Republic in 2008 to that in 2010?
Your answer should be compact. 1.09. What is the ratio of the Trade (in US$) in Angola in 2008 to that in 2011?
Offer a very short reply. 0.95. What is the ratio of the Trade (in US$) in Belize in 2008 to that in 2011?
Offer a terse response. 0.96. What is the ratio of the Trade (in US$) of Czech Republic in 2008 to that in 2011?
Offer a very short reply. 0.92. What is the ratio of the Trade (in US$) of Uganda in 2008 to that in 2011?
Give a very brief answer. 0.9. What is the ratio of the Trade (in US$) of Angola in 2008 to that in 2012?
Ensure brevity in your answer.  0.9. What is the ratio of the Trade (in US$) of Belize in 2008 to that in 2012?
Keep it short and to the point. 0.87. What is the ratio of the Trade (in US$) of Czech Republic in 2008 to that in 2012?
Your answer should be very brief. 0.94. What is the ratio of the Trade (in US$) in Uganda in 2008 to that in 2012?
Make the answer very short. 0.74. What is the ratio of the Trade (in US$) in Angola in 2009 to that in 2010?
Give a very brief answer. 0.9. What is the ratio of the Trade (in US$) of Belize in 2009 to that in 2010?
Keep it short and to the point. 0.85. What is the ratio of the Trade (in US$) of Czech Republic in 2009 to that in 2010?
Make the answer very short. 0.88. What is the ratio of the Trade (in US$) of Uganda in 2009 to that in 2010?
Give a very brief answer. 1.02. What is the ratio of the Trade (in US$) in Angola in 2009 to that in 2011?
Offer a terse response. 0.69. What is the ratio of the Trade (in US$) in Belize in 2009 to that in 2011?
Offer a terse response. 0.77. What is the ratio of the Trade (in US$) of Czech Republic in 2009 to that in 2011?
Your answer should be very brief. 0.74. What is the ratio of the Trade (in US$) of Uganda in 2009 to that in 2011?
Keep it short and to the point. 0.92. What is the ratio of the Trade (in US$) in Angola in 2009 to that in 2012?
Your response must be concise. 0.65. What is the ratio of the Trade (in US$) in Belize in 2009 to that in 2012?
Make the answer very short. 0.7. What is the ratio of the Trade (in US$) in Czech Republic in 2009 to that in 2012?
Ensure brevity in your answer.  0.76. What is the ratio of the Trade (in US$) of Uganda in 2009 to that in 2012?
Offer a very short reply. 0.76. What is the ratio of the Trade (in US$) in Angola in 2010 to that in 2011?
Your answer should be very brief. 0.76. What is the ratio of the Trade (in US$) in Belize in 2010 to that in 2011?
Keep it short and to the point. 0.91. What is the ratio of the Trade (in US$) of Czech Republic in 2010 to that in 2011?
Your answer should be compact. 0.84. What is the ratio of the Trade (in US$) in Uganda in 2010 to that in 2011?
Give a very brief answer. 0.9. What is the ratio of the Trade (in US$) in Angola in 2010 to that in 2012?
Offer a terse response. 0.72. What is the ratio of the Trade (in US$) of Belize in 2010 to that in 2012?
Ensure brevity in your answer.  0.83. What is the ratio of the Trade (in US$) of Czech Republic in 2010 to that in 2012?
Provide a short and direct response. 0.87. What is the ratio of the Trade (in US$) in Uganda in 2010 to that in 2012?
Ensure brevity in your answer.  0.74. What is the ratio of the Trade (in US$) in Angola in 2011 to that in 2012?
Your answer should be very brief. 0.95. What is the ratio of the Trade (in US$) of Belize in 2011 to that in 2012?
Your response must be concise. 0.91. What is the ratio of the Trade (in US$) of Czech Republic in 2011 to that in 2012?
Your response must be concise. 1.03. What is the ratio of the Trade (in US$) of Uganda in 2011 to that in 2012?
Offer a very short reply. 0.82. What is the difference between the highest and the second highest Trade (in US$) of Angola?
Your answer should be very brief. 3.85e+09. What is the difference between the highest and the second highest Trade (in US$) in Belize?
Offer a very short reply. 8.93e+07. What is the difference between the highest and the second highest Trade (in US$) of Czech Republic?
Ensure brevity in your answer.  4.59e+09. What is the difference between the highest and the second highest Trade (in US$) in Uganda?
Give a very brief answer. 8.39e+08. What is the difference between the highest and the lowest Trade (in US$) in Angola?
Offer a terse response. 3.84e+1. What is the difference between the highest and the lowest Trade (in US$) of Belize?
Keep it short and to the point. 2.93e+08. What is the difference between the highest and the lowest Trade (in US$) of Czech Republic?
Your answer should be compact. 6.15e+1. What is the difference between the highest and the lowest Trade (in US$) in Uganda?
Ensure brevity in your answer.  3.16e+09. 